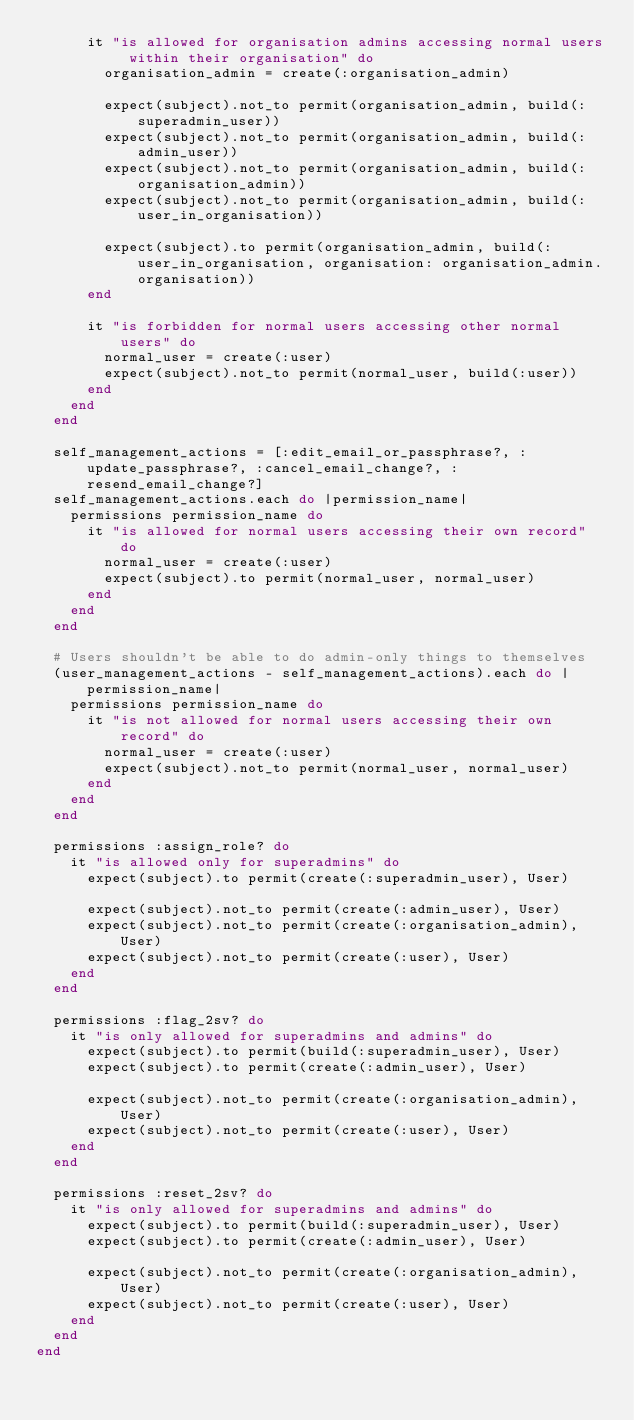Convert code to text. <code><loc_0><loc_0><loc_500><loc_500><_Ruby_>      it "is allowed for organisation admins accessing normal users within their organisation" do
        organisation_admin = create(:organisation_admin)

        expect(subject).not_to permit(organisation_admin, build(:superadmin_user))
        expect(subject).not_to permit(organisation_admin, build(:admin_user))
        expect(subject).not_to permit(organisation_admin, build(:organisation_admin))
        expect(subject).not_to permit(organisation_admin, build(:user_in_organisation))

        expect(subject).to permit(organisation_admin, build(:user_in_organisation, organisation: organisation_admin.organisation))
      end

      it "is forbidden for normal users accessing other normal users" do
        normal_user = create(:user)
        expect(subject).not_to permit(normal_user, build(:user))
      end
    end
  end

  self_management_actions = [:edit_email_or_passphrase?, :update_passphrase?, :cancel_email_change?, :resend_email_change?]
  self_management_actions.each do |permission_name|
    permissions permission_name do
      it "is allowed for normal users accessing their own record" do
        normal_user = create(:user)
        expect(subject).to permit(normal_user, normal_user)
      end
    end
  end

  # Users shouldn't be able to do admin-only things to themselves
  (user_management_actions - self_management_actions).each do |permission_name|
    permissions permission_name do
      it "is not allowed for normal users accessing their own record" do
        normal_user = create(:user)
        expect(subject).not_to permit(normal_user, normal_user)
      end
    end
  end

  permissions :assign_role? do
    it "is allowed only for superadmins" do
      expect(subject).to permit(create(:superadmin_user), User)

      expect(subject).not_to permit(create(:admin_user), User)
      expect(subject).not_to permit(create(:organisation_admin), User)
      expect(subject).not_to permit(create(:user), User)
    end
  end

  permissions :flag_2sv? do
    it "is only allowed for superadmins and admins" do
      expect(subject).to permit(build(:superadmin_user), User)
      expect(subject).to permit(create(:admin_user), User)

      expect(subject).not_to permit(create(:organisation_admin), User)
      expect(subject).not_to permit(create(:user), User)
    end
  end

  permissions :reset_2sv? do
    it "is only allowed for superadmins and admins" do
      expect(subject).to permit(build(:superadmin_user), User)
      expect(subject).to permit(create(:admin_user), User)

      expect(subject).not_to permit(create(:organisation_admin), User)
      expect(subject).not_to permit(create(:user), User)
    end
  end
end
</code> 